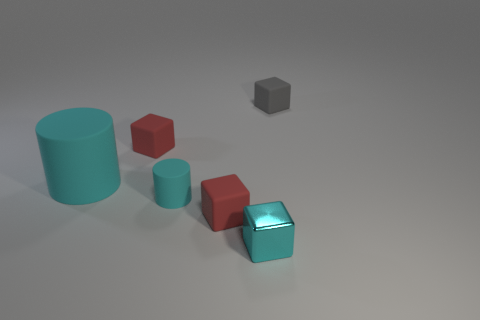Add 4 large brown shiny cubes. How many objects exist? 10 Subtract all cubes. How many objects are left? 2 Add 3 small red blocks. How many small red blocks are left? 5 Add 5 matte blocks. How many matte blocks exist? 8 Subtract 0 blue balls. How many objects are left? 6 Subtract all large purple balls. Subtract all cyan shiny things. How many objects are left? 5 